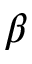<formula> <loc_0><loc_0><loc_500><loc_500>\beta</formula> 